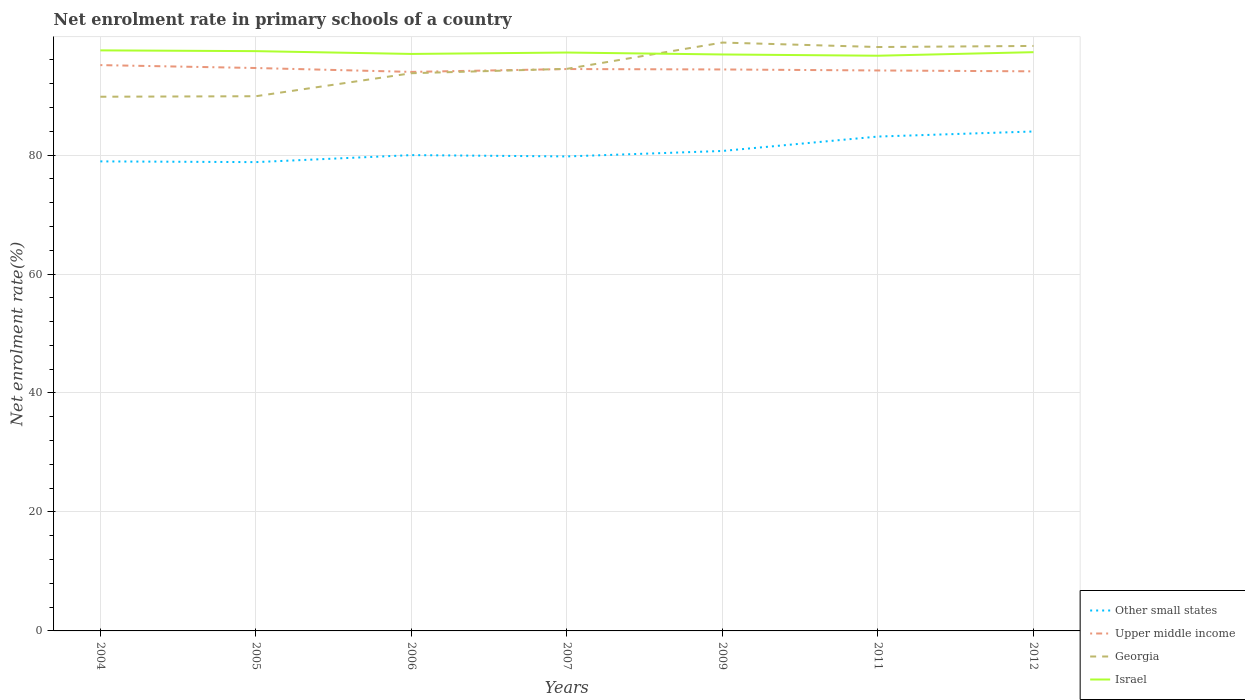How many different coloured lines are there?
Ensure brevity in your answer.  4. Does the line corresponding to Georgia intersect with the line corresponding to Upper middle income?
Provide a succinct answer. Yes. Across all years, what is the maximum net enrolment rate in primary schools in Upper middle income?
Provide a short and direct response. 93.98. What is the total net enrolment rate in primary schools in Upper middle income in the graph?
Keep it short and to the point. 0.24. What is the difference between the highest and the second highest net enrolment rate in primary schools in Israel?
Provide a short and direct response. 0.9. Is the net enrolment rate in primary schools in Georgia strictly greater than the net enrolment rate in primary schools in Upper middle income over the years?
Your answer should be very brief. No. How many lines are there?
Offer a terse response. 4. How many years are there in the graph?
Give a very brief answer. 7. Are the values on the major ticks of Y-axis written in scientific E-notation?
Provide a succinct answer. No. Does the graph contain grids?
Your answer should be compact. Yes. How many legend labels are there?
Provide a short and direct response. 4. What is the title of the graph?
Your answer should be compact. Net enrolment rate in primary schools of a country. Does "Cayman Islands" appear as one of the legend labels in the graph?
Your answer should be compact. No. What is the label or title of the Y-axis?
Ensure brevity in your answer.  Net enrolment rate(%). What is the Net enrolment rate(%) in Other small states in 2004?
Make the answer very short. 78.94. What is the Net enrolment rate(%) of Upper middle income in 2004?
Keep it short and to the point. 95.12. What is the Net enrolment rate(%) of Georgia in 2004?
Ensure brevity in your answer.  89.81. What is the Net enrolment rate(%) of Israel in 2004?
Ensure brevity in your answer.  97.6. What is the Net enrolment rate(%) of Other small states in 2005?
Provide a succinct answer. 78.81. What is the Net enrolment rate(%) of Upper middle income in 2005?
Provide a succinct answer. 94.64. What is the Net enrolment rate(%) in Georgia in 2005?
Your response must be concise. 89.89. What is the Net enrolment rate(%) in Israel in 2005?
Provide a succinct answer. 97.47. What is the Net enrolment rate(%) in Other small states in 2006?
Your answer should be compact. 79.99. What is the Net enrolment rate(%) in Upper middle income in 2006?
Your answer should be compact. 93.98. What is the Net enrolment rate(%) in Georgia in 2006?
Provide a succinct answer. 93.76. What is the Net enrolment rate(%) of Israel in 2006?
Keep it short and to the point. 97. What is the Net enrolment rate(%) in Other small states in 2007?
Ensure brevity in your answer.  79.77. What is the Net enrolment rate(%) in Upper middle income in 2007?
Provide a succinct answer. 94.46. What is the Net enrolment rate(%) in Georgia in 2007?
Offer a very short reply. 94.5. What is the Net enrolment rate(%) of Israel in 2007?
Your response must be concise. 97.24. What is the Net enrolment rate(%) of Other small states in 2009?
Provide a succinct answer. 80.69. What is the Net enrolment rate(%) of Upper middle income in 2009?
Make the answer very short. 94.39. What is the Net enrolment rate(%) of Georgia in 2009?
Your answer should be very brief. 98.92. What is the Net enrolment rate(%) of Israel in 2009?
Give a very brief answer. 96.91. What is the Net enrolment rate(%) in Other small states in 2011?
Make the answer very short. 83.11. What is the Net enrolment rate(%) of Upper middle income in 2011?
Provide a short and direct response. 94.22. What is the Net enrolment rate(%) of Georgia in 2011?
Your response must be concise. 98.16. What is the Net enrolment rate(%) of Israel in 2011?
Keep it short and to the point. 96.7. What is the Net enrolment rate(%) of Other small states in 2012?
Offer a very short reply. 83.97. What is the Net enrolment rate(%) of Upper middle income in 2012?
Provide a succinct answer. 94.08. What is the Net enrolment rate(%) in Georgia in 2012?
Ensure brevity in your answer.  98.35. What is the Net enrolment rate(%) in Israel in 2012?
Offer a terse response. 97.3. Across all years, what is the maximum Net enrolment rate(%) of Other small states?
Offer a terse response. 83.97. Across all years, what is the maximum Net enrolment rate(%) in Upper middle income?
Provide a succinct answer. 95.12. Across all years, what is the maximum Net enrolment rate(%) of Georgia?
Your response must be concise. 98.92. Across all years, what is the maximum Net enrolment rate(%) in Israel?
Your answer should be compact. 97.6. Across all years, what is the minimum Net enrolment rate(%) of Other small states?
Your answer should be compact. 78.81. Across all years, what is the minimum Net enrolment rate(%) in Upper middle income?
Your answer should be compact. 93.98. Across all years, what is the minimum Net enrolment rate(%) of Georgia?
Offer a terse response. 89.81. Across all years, what is the minimum Net enrolment rate(%) of Israel?
Ensure brevity in your answer.  96.7. What is the total Net enrolment rate(%) in Other small states in the graph?
Offer a very short reply. 565.29. What is the total Net enrolment rate(%) in Upper middle income in the graph?
Keep it short and to the point. 660.89. What is the total Net enrolment rate(%) of Georgia in the graph?
Give a very brief answer. 663.38. What is the total Net enrolment rate(%) in Israel in the graph?
Provide a short and direct response. 680.22. What is the difference between the Net enrolment rate(%) in Other small states in 2004 and that in 2005?
Provide a succinct answer. 0.12. What is the difference between the Net enrolment rate(%) in Upper middle income in 2004 and that in 2005?
Give a very brief answer. 0.49. What is the difference between the Net enrolment rate(%) in Georgia in 2004 and that in 2005?
Provide a short and direct response. -0.09. What is the difference between the Net enrolment rate(%) of Israel in 2004 and that in 2005?
Offer a very short reply. 0.13. What is the difference between the Net enrolment rate(%) in Other small states in 2004 and that in 2006?
Give a very brief answer. -1.05. What is the difference between the Net enrolment rate(%) of Upper middle income in 2004 and that in 2006?
Provide a succinct answer. 1.14. What is the difference between the Net enrolment rate(%) of Georgia in 2004 and that in 2006?
Keep it short and to the point. -3.95. What is the difference between the Net enrolment rate(%) of Israel in 2004 and that in 2006?
Your answer should be very brief. 0.6. What is the difference between the Net enrolment rate(%) in Other small states in 2004 and that in 2007?
Your response must be concise. -0.83. What is the difference between the Net enrolment rate(%) of Upper middle income in 2004 and that in 2007?
Make the answer very short. 0.66. What is the difference between the Net enrolment rate(%) in Georgia in 2004 and that in 2007?
Ensure brevity in your answer.  -4.69. What is the difference between the Net enrolment rate(%) of Israel in 2004 and that in 2007?
Give a very brief answer. 0.36. What is the difference between the Net enrolment rate(%) in Other small states in 2004 and that in 2009?
Offer a terse response. -1.75. What is the difference between the Net enrolment rate(%) of Upper middle income in 2004 and that in 2009?
Provide a succinct answer. 0.73. What is the difference between the Net enrolment rate(%) in Georgia in 2004 and that in 2009?
Keep it short and to the point. -9.11. What is the difference between the Net enrolment rate(%) in Israel in 2004 and that in 2009?
Your answer should be compact. 0.69. What is the difference between the Net enrolment rate(%) in Other small states in 2004 and that in 2011?
Offer a very short reply. -4.18. What is the difference between the Net enrolment rate(%) of Upper middle income in 2004 and that in 2011?
Your response must be concise. 0.9. What is the difference between the Net enrolment rate(%) of Georgia in 2004 and that in 2011?
Offer a very short reply. -8.36. What is the difference between the Net enrolment rate(%) in Israel in 2004 and that in 2011?
Keep it short and to the point. 0.9. What is the difference between the Net enrolment rate(%) in Other small states in 2004 and that in 2012?
Make the answer very short. -5.03. What is the difference between the Net enrolment rate(%) in Upper middle income in 2004 and that in 2012?
Your answer should be very brief. 1.05. What is the difference between the Net enrolment rate(%) in Georgia in 2004 and that in 2012?
Ensure brevity in your answer.  -8.54. What is the difference between the Net enrolment rate(%) of Israel in 2004 and that in 2012?
Keep it short and to the point. 0.3. What is the difference between the Net enrolment rate(%) in Other small states in 2005 and that in 2006?
Your response must be concise. -1.18. What is the difference between the Net enrolment rate(%) of Upper middle income in 2005 and that in 2006?
Your answer should be compact. 0.65. What is the difference between the Net enrolment rate(%) in Georgia in 2005 and that in 2006?
Your response must be concise. -3.87. What is the difference between the Net enrolment rate(%) of Israel in 2005 and that in 2006?
Your answer should be very brief. 0.47. What is the difference between the Net enrolment rate(%) in Other small states in 2005 and that in 2007?
Your answer should be compact. -0.96. What is the difference between the Net enrolment rate(%) of Upper middle income in 2005 and that in 2007?
Ensure brevity in your answer.  0.17. What is the difference between the Net enrolment rate(%) in Georgia in 2005 and that in 2007?
Provide a succinct answer. -4.61. What is the difference between the Net enrolment rate(%) of Israel in 2005 and that in 2007?
Your response must be concise. 0.23. What is the difference between the Net enrolment rate(%) in Other small states in 2005 and that in 2009?
Your answer should be very brief. -1.88. What is the difference between the Net enrolment rate(%) of Upper middle income in 2005 and that in 2009?
Provide a short and direct response. 0.24. What is the difference between the Net enrolment rate(%) of Georgia in 2005 and that in 2009?
Your response must be concise. -9.02. What is the difference between the Net enrolment rate(%) of Israel in 2005 and that in 2009?
Ensure brevity in your answer.  0.56. What is the difference between the Net enrolment rate(%) in Other small states in 2005 and that in 2011?
Your answer should be very brief. -4.3. What is the difference between the Net enrolment rate(%) of Upper middle income in 2005 and that in 2011?
Your response must be concise. 0.41. What is the difference between the Net enrolment rate(%) of Georgia in 2005 and that in 2011?
Provide a succinct answer. -8.27. What is the difference between the Net enrolment rate(%) of Israel in 2005 and that in 2011?
Give a very brief answer. 0.77. What is the difference between the Net enrolment rate(%) of Other small states in 2005 and that in 2012?
Offer a very short reply. -5.15. What is the difference between the Net enrolment rate(%) in Upper middle income in 2005 and that in 2012?
Make the answer very short. 0.56. What is the difference between the Net enrolment rate(%) in Georgia in 2005 and that in 2012?
Offer a very short reply. -8.45. What is the difference between the Net enrolment rate(%) of Israel in 2005 and that in 2012?
Offer a very short reply. 0.17. What is the difference between the Net enrolment rate(%) of Other small states in 2006 and that in 2007?
Keep it short and to the point. 0.22. What is the difference between the Net enrolment rate(%) of Upper middle income in 2006 and that in 2007?
Give a very brief answer. -0.48. What is the difference between the Net enrolment rate(%) of Georgia in 2006 and that in 2007?
Provide a short and direct response. -0.74. What is the difference between the Net enrolment rate(%) of Israel in 2006 and that in 2007?
Offer a terse response. -0.23. What is the difference between the Net enrolment rate(%) of Other small states in 2006 and that in 2009?
Your answer should be very brief. -0.7. What is the difference between the Net enrolment rate(%) in Upper middle income in 2006 and that in 2009?
Give a very brief answer. -0.41. What is the difference between the Net enrolment rate(%) in Georgia in 2006 and that in 2009?
Make the answer very short. -5.16. What is the difference between the Net enrolment rate(%) in Israel in 2006 and that in 2009?
Make the answer very short. 0.09. What is the difference between the Net enrolment rate(%) in Other small states in 2006 and that in 2011?
Provide a short and direct response. -3.12. What is the difference between the Net enrolment rate(%) in Upper middle income in 2006 and that in 2011?
Provide a short and direct response. -0.24. What is the difference between the Net enrolment rate(%) of Georgia in 2006 and that in 2011?
Keep it short and to the point. -4.4. What is the difference between the Net enrolment rate(%) of Israel in 2006 and that in 2011?
Provide a succinct answer. 0.3. What is the difference between the Net enrolment rate(%) in Other small states in 2006 and that in 2012?
Your answer should be compact. -3.97. What is the difference between the Net enrolment rate(%) of Upper middle income in 2006 and that in 2012?
Your response must be concise. -0.09. What is the difference between the Net enrolment rate(%) in Georgia in 2006 and that in 2012?
Make the answer very short. -4.59. What is the difference between the Net enrolment rate(%) of Israel in 2006 and that in 2012?
Provide a succinct answer. -0.3. What is the difference between the Net enrolment rate(%) in Other small states in 2007 and that in 2009?
Keep it short and to the point. -0.92. What is the difference between the Net enrolment rate(%) of Upper middle income in 2007 and that in 2009?
Give a very brief answer. 0.07. What is the difference between the Net enrolment rate(%) of Georgia in 2007 and that in 2009?
Ensure brevity in your answer.  -4.42. What is the difference between the Net enrolment rate(%) of Israel in 2007 and that in 2009?
Provide a succinct answer. 0.33. What is the difference between the Net enrolment rate(%) in Other small states in 2007 and that in 2011?
Provide a short and direct response. -3.34. What is the difference between the Net enrolment rate(%) in Upper middle income in 2007 and that in 2011?
Provide a short and direct response. 0.24. What is the difference between the Net enrolment rate(%) in Georgia in 2007 and that in 2011?
Make the answer very short. -3.66. What is the difference between the Net enrolment rate(%) in Israel in 2007 and that in 2011?
Your answer should be compact. 0.54. What is the difference between the Net enrolment rate(%) in Other small states in 2007 and that in 2012?
Offer a terse response. -4.19. What is the difference between the Net enrolment rate(%) of Upper middle income in 2007 and that in 2012?
Provide a succinct answer. 0.39. What is the difference between the Net enrolment rate(%) of Georgia in 2007 and that in 2012?
Provide a succinct answer. -3.85. What is the difference between the Net enrolment rate(%) in Israel in 2007 and that in 2012?
Offer a terse response. -0.06. What is the difference between the Net enrolment rate(%) of Other small states in 2009 and that in 2011?
Provide a succinct answer. -2.42. What is the difference between the Net enrolment rate(%) in Upper middle income in 2009 and that in 2011?
Give a very brief answer. 0.17. What is the difference between the Net enrolment rate(%) of Georgia in 2009 and that in 2011?
Your response must be concise. 0.75. What is the difference between the Net enrolment rate(%) of Israel in 2009 and that in 2011?
Provide a short and direct response. 0.21. What is the difference between the Net enrolment rate(%) of Other small states in 2009 and that in 2012?
Your answer should be very brief. -3.28. What is the difference between the Net enrolment rate(%) of Upper middle income in 2009 and that in 2012?
Make the answer very short. 0.32. What is the difference between the Net enrolment rate(%) in Georgia in 2009 and that in 2012?
Keep it short and to the point. 0.57. What is the difference between the Net enrolment rate(%) in Israel in 2009 and that in 2012?
Make the answer very short. -0.39. What is the difference between the Net enrolment rate(%) of Other small states in 2011 and that in 2012?
Provide a short and direct response. -0.85. What is the difference between the Net enrolment rate(%) of Upper middle income in 2011 and that in 2012?
Keep it short and to the point. 0.15. What is the difference between the Net enrolment rate(%) of Georgia in 2011 and that in 2012?
Keep it short and to the point. -0.18. What is the difference between the Net enrolment rate(%) of Israel in 2011 and that in 2012?
Ensure brevity in your answer.  -0.6. What is the difference between the Net enrolment rate(%) of Other small states in 2004 and the Net enrolment rate(%) of Upper middle income in 2005?
Make the answer very short. -15.7. What is the difference between the Net enrolment rate(%) of Other small states in 2004 and the Net enrolment rate(%) of Georgia in 2005?
Keep it short and to the point. -10.95. What is the difference between the Net enrolment rate(%) of Other small states in 2004 and the Net enrolment rate(%) of Israel in 2005?
Keep it short and to the point. -18.53. What is the difference between the Net enrolment rate(%) of Upper middle income in 2004 and the Net enrolment rate(%) of Georgia in 2005?
Give a very brief answer. 5.23. What is the difference between the Net enrolment rate(%) of Upper middle income in 2004 and the Net enrolment rate(%) of Israel in 2005?
Your answer should be compact. -2.35. What is the difference between the Net enrolment rate(%) of Georgia in 2004 and the Net enrolment rate(%) of Israel in 2005?
Give a very brief answer. -7.66. What is the difference between the Net enrolment rate(%) of Other small states in 2004 and the Net enrolment rate(%) of Upper middle income in 2006?
Your answer should be very brief. -15.04. What is the difference between the Net enrolment rate(%) in Other small states in 2004 and the Net enrolment rate(%) in Georgia in 2006?
Your response must be concise. -14.82. What is the difference between the Net enrolment rate(%) of Other small states in 2004 and the Net enrolment rate(%) of Israel in 2006?
Offer a terse response. -18.06. What is the difference between the Net enrolment rate(%) of Upper middle income in 2004 and the Net enrolment rate(%) of Georgia in 2006?
Make the answer very short. 1.36. What is the difference between the Net enrolment rate(%) in Upper middle income in 2004 and the Net enrolment rate(%) in Israel in 2006?
Give a very brief answer. -1.88. What is the difference between the Net enrolment rate(%) of Georgia in 2004 and the Net enrolment rate(%) of Israel in 2006?
Make the answer very short. -7.2. What is the difference between the Net enrolment rate(%) in Other small states in 2004 and the Net enrolment rate(%) in Upper middle income in 2007?
Provide a short and direct response. -15.52. What is the difference between the Net enrolment rate(%) in Other small states in 2004 and the Net enrolment rate(%) in Georgia in 2007?
Offer a terse response. -15.56. What is the difference between the Net enrolment rate(%) in Other small states in 2004 and the Net enrolment rate(%) in Israel in 2007?
Offer a terse response. -18.3. What is the difference between the Net enrolment rate(%) in Upper middle income in 2004 and the Net enrolment rate(%) in Georgia in 2007?
Your answer should be compact. 0.63. What is the difference between the Net enrolment rate(%) of Upper middle income in 2004 and the Net enrolment rate(%) of Israel in 2007?
Keep it short and to the point. -2.11. What is the difference between the Net enrolment rate(%) of Georgia in 2004 and the Net enrolment rate(%) of Israel in 2007?
Your answer should be very brief. -7.43. What is the difference between the Net enrolment rate(%) in Other small states in 2004 and the Net enrolment rate(%) in Upper middle income in 2009?
Provide a short and direct response. -15.45. What is the difference between the Net enrolment rate(%) in Other small states in 2004 and the Net enrolment rate(%) in Georgia in 2009?
Your answer should be very brief. -19.98. What is the difference between the Net enrolment rate(%) of Other small states in 2004 and the Net enrolment rate(%) of Israel in 2009?
Your answer should be very brief. -17.97. What is the difference between the Net enrolment rate(%) in Upper middle income in 2004 and the Net enrolment rate(%) in Georgia in 2009?
Your answer should be compact. -3.79. What is the difference between the Net enrolment rate(%) of Upper middle income in 2004 and the Net enrolment rate(%) of Israel in 2009?
Offer a terse response. -1.79. What is the difference between the Net enrolment rate(%) in Georgia in 2004 and the Net enrolment rate(%) in Israel in 2009?
Ensure brevity in your answer.  -7.1. What is the difference between the Net enrolment rate(%) of Other small states in 2004 and the Net enrolment rate(%) of Upper middle income in 2011?
Offer a very short reply. -15.29. What is the difference between the Net enrolment rate(%) of Other small states in 2004 and the Net enrolment rate(%) of Georgia in 2011?
Your answer should be compact. -19.22. What is the difference between the Net enrolment rate(%) in Other small states in 2004 and the Net enrolment rate(%) in Israel in 2011?
Keep it short and to the point. -17.76. What is the difference between the Net enrolment rate(%) of Upper middle income in 2004 and the Net enrolment rate(%) of Georgia in 2011?
Your answer should be compact. -3.04. What is the difference between the Net enrolment rate(%) of Upper middle income in 2004 and the Net enrolment rate(%) of Israel in 2011?
Offer a very short reply. -1.58. What is the difference between the Net enrolment rate(%) of Georgia in 2004 and the Net enrolment rate(%) of Israel in 2011?
Your answer should be compact. -6.89. What is the difference between the Net enrolment rate(%) of Other small states in 2004 and the Net enrolment rate(%) of Upper middle income in 2012?
Your response must be concise. -15.14. What is the difference between the Net enrolment rate(%) of Other small states in 2004 and the Net enrolment rate(%) of Georgia in 2012?
Offer a very short reply. -19.41. What is the difference between the Net enrolment rate(%) in Other small states in 2004 and the Net enrolment rate(%) in Israel in 2012?
Offer a terse response. -18.36. What is the difference between the Net enrolment rate(%) of Upper middle income in 2004 and the Net enrolment rate(%) of Georgia in 2012?
Your answer should be compact. -3.22. What is the difference between the Net enrolment rate(%) in Upper middle income in 2004 and the Net enrolment rate(%) in Israel in 2012?
Give a very brief answer. -2.18. What is the difference between the Net enrolment rate(%) in Georgia in 2004 and the Net enrolment rate(%) in Israel in 2012?
Ensure brevity in your answer.  -7.49. What is the difference between the Net enrolment rate(%) of Other small states in 2005 and the Net enrolment rate(%) of Upper middle income in 2006?
Make the answer very short. -15.17. What is the difference between the Net enrolment rate(%) in Other small states in 2005 and the Net enrolment rate(%) in Georgia in 2006?
Offer a very short reply. -14.94. What is the difference between the Net enrolment rate(%) in Other small states in 2005 and the Net enrolment rate(%) in Israel in 2006?
Give a very brief answer. -18.19. What is the difference between the Net enrolment rate(%) in Upper middle income in 2005 and the Net enrolment rate(%) in Georgia in 2006?
Make the answer very short. 0.88. What is the difference between the Net enrolment rate(%) in Upper middle income in 2005 and the Net enrolment rate(%) in Israel in 2006?
Offer a very short reply. -2.37. What is the difference between the Net enrolment rate(%) in Georgia in 2005 and the Net enrolment rate(%) in Israel in 2006?
Your answer should be very brief. -7.11. What is the difference between the Net enrolment rate(%) of Other small states in 2005 and the Net enrolment rate(%) of Upper middle income in 2007?
Offer a terse response. -15.65. What is the difference between the Net enrolment rate(%) of Other small states in 2005 and the Net enrolment rate(%) of Georgia in 2007?
Offer a terse response. -15.68. What is the difference between the Net enrolment rate(%) in Other small states in 2005 and the Net enrolment rate(%) in Israel in 2007?
Make the answer very short. -18.42. What is the difference between the Net enrolment rate(%) of Upper middle income in 2005 and the Net enrolment rate(%) of Georgia in 2007?
Keep it short and to the point. 0.14. What is the difference between the Net enrolment rate(%) of Upper middle income in 2005 and the Net enrolment rate(%) of Israel in 2007?
Your answer should be very brief. -2.6. What is the difference between the Net enrolment rate(%) in Georgia in 2005 and the Net enrolment rate(%) in Israel in 2007?
Give a very brief answer. -7.34. What is the difference between the Net enrolment rate(%) of Other small states in 2005 and the Net enrolment rate(%) of Upper middle income in 2009?
Your response must be concise. -15.58. What is the difference between the Net enrolment rate(%) of Other small states in 2005 and the Net enrolment rate(%) of Georgia in 2009?
Offer a very short reply. -20.1. What is the difference between the Net enrolment rate(%) of Other small states in 2005 and the Net enrolment rate(%) of Israel in 2009?
Keep it short and to the point. -18.1. What is the difference between the Net enrolment rate(%) in Upper middle income in 2005 and the Net enrolment rate(%) in Georgia in 2009?
Provide a short and direct response. -4.28. What is the difference between the Net enrolment rate(%) in Upper middle income in 2005 and the Net enrolment rate(%) in Israel in 2009?
Ensure brevity in your answer.  -2.28. What is the difference between the Net enrolment rate(%) in Georgia in 2005 and the Net enrolment rate(%) in Israel in 2009?
Make the answer very short. -7.02. What is the difference between the Net enrolment rate(%) in Other small states in 2005 and the Net enrolment rate(%) in Upper middle income in 2011?
Your response must be concise. -15.41. What is the difference between the Net enrolment rate(%) in Other small states in 2005 and the Net enrolment rate(%) in Georgia in 2011?
Provide a short and direct response. -19.35. What is the difference between the Net enrolment rate(%) in Other small states in 2005 and the Net enrolment rate(%) in Israel in 2011?
Your response must be concise. -17.89. What is the difference between the Net enrolment rate(%) in Upper middle income in 2005 and the Net enrolment rate(%) in Georgia in 2011?
Offer a terse response. -3.53. What is the difference between the Net enrolment rate(%) of Upper middle income in 2005 and the Net enrolment rate(%) of Israel in 2011?
Offer a terse response. -2.07. What is the difference between the Net enrolment rate(%) of Georgia in 2005 and the Net enrolment rate(%) of Israel in 2011?
Ensure brevity in your answer.  -6.81. What is the difference between the Net enrolment rate(%) of Other small states in 2005 and the Net enrolment rate(%) of Upper middle income in 2012?
Offer a very short reply. -15.26. What is the difference between the Net enrolment rate(%) in Other small states in 2005 and the Net enrolment rate(%) in Georgia in 2012?
Your answer should be very brief. -19.53. What is the difference between the Net enrolment rate(%) of Other small states in 2005 and the Net enrolment rate(%) of Israel in 2012?
Offer a terse response. -18.48. What is the difference between the Net enrolment rate(%) of Upper middle income in 2005 and the Net enrolment rate(%) of Georgia in 2012?
Offer a terse response. -3.71. What is the difference between the Net enrolment rate(%) of Upper middle income in 2005 and the Net enrolment rate(%) of Israel in 2012?
Offer a very short reply. -2.66. What is the difference between the Net enrolment rate(%) of Georgia in 2005 and the Net enrolment rate(%) of Israel in 2012?
Make the answer very short. -7.41. What is the difference between the Net enrolment rate(%) in Other small states in 2006 and the Net enrolment rate(%) in Upper middle income in 2007?
Make the answer very short. -14.47. What is the difference between the Net enrolment rate(%) in Other small states in 2006 and the Net enrolment rate(%) in Georgia in 2007?
Your answer should be very brief. -14.51. What is the difference between the Net enrolment rate(%) of Other small states in 2006 and the Net enrolment rate(%) of Israel in 2007?
Your answer should be compact. -17.25. What is the difference between the Net enrolment rate(%) in Upper middle income in 2006 and the Net enrolment rate(%) in Georgia in 2007?
Make the answer very short. -0.52. What is the difference between the Net enrolment rate(%) in Upper middle income in 2006 and the Net enrolment rate(%) in Israel in 2007?
Offer a terse response. -3.26. What is the difference between the Net enrolment rate(%) of Georgia in 2006 and the Net enrolment rate(%) of Israel in 2007?
Your answer should be compact. -3.48. What is the difference between the Net enrolment rate(%) of Other small states in 2006 and the Net enrolment rate(%) of Upper middle income in 2009?
Keep it short and to the point. -14.4. What is the difference between the Net enrolment rate(%) of Other small states in 2006 and the Net enrolment rate(%) of Georgia in 2009?
Keep it short and to the point. -18.92. What is the difference between the Net enrolment rate(%) in Other small states in 2006 and the Net enrolment rate(%) in Israel in 2009?
Your response must be concise. -16.92. What is the difference between the Net enrolment rate(%) in Upper middle income in 2006 and the Net enrolment rate(%) in Georgia in 2009?
Ensure brevity in your answer.  -4.93. What is the difference between the Net enrolment rate(%) in Upper middle income in 2006 and the Net enrolment rate(%) in Israel in 2009?
Your answer should be compact. -2.93. What is the difference between the Net enrolment rate(%) of Georgia in 2006 and the Net enrolment rate(%) of Israel in 2009?
Provide a succinct answer. -3.15. What is the difference between the Net enrolment rate(%) in Other small states in 2006 and the Net enrolment rate(%) in Upper middle income in 2011?
Your answer should be very brief. -14.23. What is the difference between the Net enrolment rate(%) of Other small states in 2006 and the Net enrolment rate(%) of Georgia in 2011?
Your answer should be very brief. -18.17. What is the difference between the Net enrolment rate(%) of Other small states in 2006 and the Net enrolment rate(%) of Israel in 2011?
Keep it short and to the point. -16.71. What is the difference between the Net enrolment rate(%) of Upper middle income in 2006 and the Net enrolment rate(%) of Georgia in 2011?
Your response must be concise. -4.18. What is the difference between the Net enrolment rate(%) in Upper middle income in 2006 and the Net enrolment rate(%) in Israel in 2011?
Keep it short and to the point. -2.72. What is the difference between the Net enrolment rate(%) of Georgia in 2006 and the Net enrolment rate(%) of Israel in 2011?
Your response must be concise. -2.94. What is the difference between the Net enrolment rate(%) of Other small states in 2006 and the Net enrolment rate(%) of Upper middle income in 2012?
Provide a succinct answer. -14.08. What is the difference between the Net enrolment rate(%) of Other small states in 2006 and the Net enrolment rate(%) of Georgia in 2012?
Your response must be concise. -18.35. What is the difference between the Net enrolment rate(%) of Other small states in 2006 and the Net enrolment rate(%) of Israel in 2012?
Ensure brevity in your answer.  -17.31. What is the difference between the Net enrolment rate(%) in Upper middle income in 2006 and the Net enrolment rate(%) in Georgia in 2012?
Provide a succinct answer. -4.36. What is the difference between the Net enrolment rate(%) of Upper middle income in 2006 and the Net enrolment rate(%) of Israel in 2012?
Keep it short and to the point. -3.32. What is the difference between the Net enrolment rate(%) in Georgia in 2006 and the Net enrolment rate(%) in Israel in 2012?
Give a very brief answer. -3.54. What is the difference between the Net enrolment rate(%) of Other small states in 2007 and the Net enrolment rate(%) of Upper middle income in 2009?
Provide a succinct answer. -14.62. What is the difference between the Net enrolment rate(%) in Other small states in 2007 and the Net enrolment rate(%) in Georgia in 2009?
Provide a short and direct response. -19.14. What is the difference between the Net enrolment rate(%) of Other small states in 2007 and the Net enrolment rate(%) of Israel in 2009?
Provide a short and direct response. -17.14. What is the difference between the Net enrolment rate(%) of Upper middle income in 2007 and the Net enrolment rate(%) of Georgia in 2009?
Offer a terse response. -4.45. What is the difference between the Net enrolment rate(%) of Upper middle income in 2007 and the Net enrolment rate(%) of Israel in 2009?
Your response must be concise. -2.45. What is the difference between the Net enrolment rate(%) of Georgia in 2007 and the Net enrolment rate(%) of Israel in 2009?
Your answer should be very brief. -2.41. What is the difference between the Net enrolment rate(%) in Other small states in 2007 and the Net enrolment rate(%) in Upper middle income in 2011?
Offer a terse response. -14.45. What is the difference between the Net enrolment rate(%) in Other small states in 2007 and the Net enrolment rate(%) in Georgia in 2011?
Your response must be concise. -18.39. What is the difference between the Net enrolment rate(%) of Other small states in 2007 and the Net enrolment rate(%) of Israel in 2011?
Provide a short and direct response. -16.93. What is the difference between the Net enrolment rate(%) of Upper middle income in 2007 and the Net enrolment rate(%) of Georgia in 2011?
Offer a terse response. -3.7. What is the difference between the Net enrolment rate(%) of Upper middle income in 2007 and the Net enrolment rate(%) of Israel in 2011?
Provide a short and direct response. -2.24. What is the difference between the Net enrolment rate(%) in Georgia in 2007 and the Net enrolment rate(%) in Israel in 2011?
Your answer should be very brief. -2.2. What is the difference between the Net enrolment rate(%) of Other small states in 2007 and the Net enrolment rate(%) of Upper middle income in 2012?
Ensure brevity in your answer.  -14.3. What is the difference between the Net enrolment rate(%) in Other small states in 2007 and the Net enrolment rate(%) in Georgia in 2012?
Your answer should be very brief. -18.57. What is the difference between the Net enrolment rate(%) in Other small states in 2007 and the Net enrolment rate(%) in Israel in 2012?
Ensure brevity in your answer.  -17.53. What is the difference between the Net enrolment rate(%) of Upper middle income in 2007 and the Net enrolment rate(%) of Georgia in 2012?
Keep it short and to the point. -3.88. What is the difference between the Net enrolment rate(%) in Upper middle income in 2007 and the Net enrolment rate(%) in Israel in 2012?
Ensure brevity in your answer.  -2.84. What is the difference between the Net enrolment rate(%) in Georgia in 2007 and the Net enrolment rate(%) in Israel in 2012?
Ensure brevity in your answer.  -2.8. What is the difference between the Net enrolment rate(%) of Other small states in 2009 and the Net enrolment rate(%) of Upper middle income in 2011?
Give a very brief answer. -13.53. What is the difference between the Net enrolment rate(%) in Other small states in 2009 and the Net enrolment rate(%) in Georgia in 2011?
Offer a terse response. -17.47. What is the difference between the Net enrolment rate(%) of Other small states in 2009 and the Net enrolment rate(%) of Israel in 2011?
Provide a short and direct response. -16.01. What is the difference between the Net enrolment rate(%) in Upper middle income in 2009 and the Net enrolment rate(%) in Georgia in 2011?
Your response must be concise. -3.77. What is the difference between the Net enrolment rate(%) of Upper middle income in 2009 and the Net enrolment rate(%) of Israel in 2011?
Offer a very short reply. -2.31. What is the difference between the Net enrolment rate(%) of Georgia in 2009 and the Net enrolment rate(%) of Israel in 2011?
Your answer should be very brief. 2.21. What is the difference between the Net enrolment rate(%) of Other small states in 2009 and the Net enrolment rate(%) of Upper middle income in 2012?
Provide a short and direct response. -13.39. What is the difference between the Net enrolment rate(%) of Other small states in 2009 and the Net enrolment rate(%) of Georgia in 2012?
Provide a succinct answer. -17.66. What is the difference between the Net enrolment rate(%) in Other small states in 2009 and the Net enrolment rate(%) in Israel in 2012?
Offer a very short reply. -16.61. What is the difference between the Net enrolment rate(%) of Upper middle income in 2009 and the Net enrolment rate(%) of Georgia in 2012?
Offer a very short reply. -3.95. What is the difference between the Net enrolment rate(%) in Upper middle income in 2009 and the Net enrolment rate(%) in Israel in 2012?
Offer a very short reply. -2.91. What is the difference between the Net enrolment rate(%) of Georgia in 2009 and the Net enrolment rate(%) of Israel in 2012?
Give a very brief answer. 1.62. What is the difference between the Net enrolment rate(%) of Other small states in 2011 and the Net enrolment rate(%) of Upper middle income in 2012?
Give a very brief answer. -10.96. What is the difference between the Net enrolment rate(%) in Other small states in 2011 and the Net enrolment rate(%) in Georgia in 2012?
Your answer should be compact. -15.23. What is the difference between the Net enrolment rate(%) in Other small states in 2011 and the Net enrolment rate(%) in Israel in 2012?
Offer a very short reply. -14.19. What is the difference between the Net enrolment rate(%) of Upper middle income in 2011 and the Net enrolment rate(%) of Georgia in 2012?
Offer a terse response. -4.12. What is the difference between the Net enrolment rate(%) of Upper middle income in 2011 and the Net enrolment rate(%) of Israel in 2012?
Your answer should be very brief. -3.08. What is the difference between the Net enrolment rate(%) in Georgia in 2011 and the Net enrolment rate(%) in Israel in 2012?
Offer a terse response. 0.86. What is the average Net enrolment rate(%) in Other small states per year?
Your answer should be compact. 80.76. What is the average Net enrolment rate(%) in Upper middle income per year?
Offer a very short reply. 94.41. What is the average Net enrolment rate(%) in Georgia per year?
Give a very brief answer. 94.77. What is the average Net enrolment rate(%) of Israel per year?
Offer a very short reply. 97.17. In the year 2004, what is the difference between the Net enrolment rate(%) in Other small states and Net enrolment rate(%) in Upper middle income?
Keep it short and to the point. -16.19. In the year 2004, what is the difference between the Net enrolment rate(%) in Other small states and Net enrolment rate(%) in Georgia?
Give a very brief answer. -10.87. In the year 2004, what is the difference between the Net enrolment rate(%) in Other small states and Net enrolment rate(%) in Israel?
Provide a succinct answer. -18.66. In the year 2004, what is the difference between the Net enrolment rate(%) of Upper middle income and Net enrolment rate(%) of Georgia?
Provide a succinct answer. 5.32. In the year 2004, what is the difference between the Net enrolment rate(%) of Upper middle income and Net enrolment rate(%) of Israel?
Provide a succinct answer. -2.48. In the year 2004, what is the difference between the Net enrolment rate(%) in Georgia and Net enrolment rate(%) in Israel?
Your answer should be very brief. -7.79. In the year 2005, what is the difference between the Net enrolment rate(%) of Other small states and Net enrolment rate(%) of Upper middle income?
Your answer should be very brief. -15.82. In the year 2005, what is the difference between the Net enrolment rate(%) of Other small states and Net enrolment rate(%) of Georgia?
Give a very brief answer. -11.08. In the year 2005, what is the difference between the Net enrolment rate(%) in Other small states and Net enrolment rate(%) in Israel?
Give a very brief answer. -18.66. In the year 2005, what is the difference between the Net enrolment rate(%) of Upper middle income and Net enrolment rate(%) of Georgia?
Your response must be concise. 4.74. In the year 2005, what is the difference between the Net enrolment rate(%) of Upper middle income and Net enrolment rate(%) of Israel?
Your answer should be compact. -2.84. In the year 2005, what is the difference between the Net enrolment rate(%) of Georgia and Net enrolment rate(%) of Israel?
Give a very brief answer. -7.58. In the year 2006, what is the difference between the Net enrolment rate(%) in Other small states and Net enrolment rate(%) in Upper middle income?
Make the answer very short. -13.99. In the year 2006, what is the difference between the Net enrolment rate(%) of Other small states and Net enrolment rate(%) of Georgia?
Offer a terse response. -13.77. In the year 2006, what is the difference between the Net enrolment rate(%) of Other small states and Net enrolment rate(%) of Israel?
Your answer should be compact. -17.01. In the year 2006, what is the difference between the Net enrolment rate(%) of Upper middle income and Net enrolment rate(%) of Georgia?
Keep it short and to the point. 0.22. In the year 2006, what is the difference between the Net enrolment rate(%) in Upper middle income and Net enrolment rate(%) in Israel?
Your response must be concise. -3.02. In the year 2006, what is the difference between the Net enrolment rate(%) in Georgia and Net enrolment rate(%) in Israel?
Offer a very short reply. -3.24. In the year 2007, what is the difference between the Net enrolment rate(%) of Other small states and Net enrolment rate(%) of Upper middle income?
Give a very brief answer. -14.69. In the year 2007, what is the difference between the Net enrolment rate(%) of Other small states and Net enrolment rate(%) of Georgia?
Provide a short and direct response. -14.73. In the year 2007, what is the difference between the Net enrolment rate(%) of Other small states and Net enrolment rate(%) of Israel?
Provide a succinct answer. -17.47. In the year 2007, what is the difference between the Net enrolment rate(%) in Upper middle income and Net enrolment rate(%) in Georgia?
Keep it short and to the point. -0.04. In the year 2007, what is the difference between the Net enrolment rate(%) in Upper middle income and Net enrolment rate(%) in Israel?
Offer a terse response. -2.78. In the year 2007, what is the difference between the Net enrolment rate(%) of Georgia and Net enrolment rate(%) of Israel?
Give a very brief answer. -2.74. In the year 2009, what is the difference between the Net enrolment rate(%) of Other small states and Net enrolment rate(%) of Upper middle income?
Offer a terse response. -13.7. In the year 2009, what is the difference between the Net enrolment rate(%) of Other small states and Net enrolment rate(%) of Georgia?
Your response must be concise. -18.23. In the year 2009, what is the difference between the Net enrolment rate(%) of Other small states and Net enrolment rate(%) of Israel?
Make the answer very short. -16.22. In the year 2009, what is the difference between the Net enrolment rate(%) of Upper middle income and Net enrolment rate(%) of Georgia?
Give a very brief answer. -4.52. In the year 2009, what is the difference between the Net enrolment rate(%) of Upper middle income and Net enrolment rate(%) of Israel?
Provide a succinct answer. -2.52. In the year 2009, what is the difference between the Net enrolment rate(%) in Georgia and Net enrolment rate(%) in Israel?
Make the answer very short. 2. In the year 2011, what is the difference between the Net enrolment rate(%) of Other small states and Net enrolment rate(%) of Upper middle income?
Provide a succinct answer. -11.11. In the year 2011, what is the difference between the Net enrolment rate(%) in Other small states and Net enrolment rate(%) in Georgia?
Offer a very short reply. -15.05. In the year 2011, what is the difference between the Net enrolment rate(%) of Other small states and Net enrolment rate(%) of Israel?
Ensure brevity in your answer.  -13.59. In the year 2011, what is the difference between the Net enrolment rate(%) of Upper middle income and Net enrolment rate(%) of Georgia?
Your answer should be compact. -3.94. In the year 2011, what is the difference between the Net enrolment rate(%) of Upper middle income and Net enrolment rate(%) of Israel?
Your answer should be very brief. -2.48. In the year 2011, what is the difference between the Net enrolment rate(%) of Georgia and Net enrolment rate(%) of Israel?
Provide a succinct answer. 1.46. In the year 2012, what is the difference between the Net enrolment rate(%) of Other small states and Net enrolment rate(%) of Upper middle income?
Provide a short and direct response. -10.11. In the year 2012, what is the difference between the Net enrolment rate(%) in Other small states and Net enrolment rate(%) in Georgia?
Give a very brief answer. -14.38. In the year 2012, what is the difference between the Net enrolment rate(%) in Other small states and Net enrolment rate(%) in Israel?
Your response must be concise. -13.33. In the year 2012, what is the difference between the Net enrolment rate(%) of Upper middle income and Net enrolment rate(%) of Georgia?
Give a very brief answer. -4.27. In the year 2012, what is the difference between the Net enrolment rate(%) of Upper middle income and Net enrolment rate(%) of Israel?
Offer a very short reply. -3.22. In the year 2012, what is the difference between the Net enrolment rate(%) in Georgia and Net enrolment rate(%) in Israel?
Give a very brief answer. 1.05. What is the ratio of the Net enrolment rate(%) in Other small states in 2004 to that in 2005?
Make the answer very short. 1. What is the ratio of the Net enrolment rate(%) in Upper middle income in 2004 to that in 2005?
Offer a very short reply. 1.01. What is the ratio of the Net enrolment rate(%) of Georgia in 2004 to that in 2005?
Provide a succinct answer. 1. What is the ratio of the Net enrolment rate(%) in Israel in 2004 to that in 2005?
Make the answer very short. 1. What is the ratio of the Net enrolment rate(%) of Other small states in 2004 to that in 2006?
Your response must be concise. 0.99. What is the ratio of the Net enrolment rate(%) in Upper middle income in 2004 to that in 2006?
Offer a terse response. 1.01. What is the ratio of the Net enrolment rate(%) of Georgia in 2004 to that in 2006?
Ensure brevity in your answer.  0.96. What is the ratio of the Net enrolment rate(%) in Israel in 2004 to that in 2006?
Your answer should be compact. 1.01. What is the ratio of the Net enrolment rate(%) of Other small states in 2004 to that in 2007?
Your answer should be compact. 0.99. What is the ratio of the Net enrolment rate(%) in Upper middle income in 2004 to that in 2007?
Your answer should be compact. 1.01. What is the ratio of the Net enrolment rate(%) in Georgia in 2004 to that in 2007?
Your answer should be compact. 0.95. What is the ratio of the Net enrolment rate(%) of Other small states in 2004 to that in 2009?
Your answer should be very brief. 0.98. What is the ratio of the Net enrolment rate(%) in Georgia in 2004 to that in 2009?
Provide a succinct answer. 0.91. What is the ratio of the Net enrolment rate(%) in Israel in 2004 to that in 2009?
Ensure brevity in your answer.  1.01. What is the ratio of the Net enrolment rate(%) in Other small states in 2004 to that in 2011?
Provide a short and direct response. 0.95. What is the ratio of the Net enrolment rate(%) in Upper middle income in 2004 to that in 2011?
Your response must be concise. 1.01. What is the ratio of the Net enrolment rate(%) of Georgia in 2004 to that in 2011?
Give a very brief answer. 0.91. What is the ratio of the Net enrolment rate(%) of Israel in 2004 to that in 2011?
Make the answer very short. 1.01. What is the ratio of the Net enrolment rate(%) of Other small states in 2004 to that in 2012?
Make the answer very short. 0.94. What is the ratio of the Net enrolment rate(%) of Upper middle income in 2004 to that in 2012?
Ensure brevity in your answer.  1.01. What is the ratio of the Net enrolment rate(%) of Georgia in 2004 to that in 2012?
Provide a succinct answer. 0.91. What is the ratio of the Net enrolment rate(%) in Israel in 2004 to that in 2012?
Keep it short and to the point. 1. What is the ratio of the Net enrolment rate(%) of Georgia in 2005 to that in 2006?
Provide a succinct answer. 0.96. What is the ratio of the Net enrolment rate(%) in Upper middle income in 2005 to that in 2007?
Keep it short and to the point. 1. What is the ratio of the Net enrolment rate(%) of Georgia in 2005 to that in 2007?
Provide a succinct answer. 0.95. What is the ratio of the Net enrolment rate(%) in Israel in 2005 to that in 2007?
Your answer should be compact. 1. What is the ratio of the Net enrolment rate(%) of Other small states in 2005 to that in 2009?
Provide a short and direct response. 0.98. What is the ratio of the Net enrolment rate(%) in Georgia in 2005 to that in 2009?
Provide a short and direct response. 0.91. What is the ratio of the Net enrolment rate(%) in Israel in 2005 to that in 2009?
Make the answer very short. 1.01. What is the ratio of the Net enrolment rate(%) in Other small states in 2005 to that in 2011?
Offer a terse response. 0.95. What is the ratio of the Net enrolment rate(%) of Upper middle income in 2005 to that in 2011?
Ensure brevity in your answer.  1. What is the ratio of the Net enrolment rate(%) in Georgia in 2005 to that in 2011?
Your answer should be very brief. 0.92. What is the ratio of the Net enrolment rate(%) of Israel in 2005 to that in 2011?
Give a very brief answer. 1.01. What is the ratio of the Net enrolment rate(%) in Other small states in 2005 to that in 2012?
Give a very brief answer. 0.94. What is the ratio of the Net enrolment rate(%) in Upper middle income in 2005 to that in 2012?
Ensure brevity in your answer.  1.01. What is the ratio of the Net enrolment rate(%) in Georgia in 2005 to that in 2012?
Offer a terse response. 0.91. What is the ratio of the Net enrolment rate(%) in Israel in 2005 to that in 2012?
Provide a short and direct response. 1. What is the ratio of the Net enrolment rate(%) in Other small states in 2006 to that in 2007?
Keep it short and to the point. 1. What is the ratio of the Net enrolment rate(%) in Georgia in 2006 to that in 2007?
Keep it short and to the point. 0.99. What is the ratio of the Net enrolment rate(%) of Other small states in 2006 to that in 2009?
Ensure brevity in your answer.  0.99. What is the ratio of the Net enrolment rate(%) in Upper middle income in 2006 to that in 2009?
Offer a very short reply. 1. What is the ratio of the Net enrolment rate(%) in Georgia in 2006 to that in 2009?
Keep it short and to the point. 0.95. What is the ratio of the Net enrolment rate(%) of Israel in 2006 to that in 2009?
Your answer should be compact. 1. What is the ratio of the Net enrolment rate(%) of Other small states in 2006 to that in 2011?
Give a very brief answer. 0.96. What is the ratio of the Net enrolment rate(%) in Upper middle income in 2006 to that in 2011?
Give a very brief answer. 1. What is the ratio of the Net enrolment rate(%) of Georgia in 2006 to that in 2011?
Your answer should be very brief. 0.96. What is the ratio of the Net enrolment rate(%) of Israel in 2006 to that in 2011?
Keep it short and to the point. 1. What is the ratio of the Net enrolment rate(%) in Other small states in 2006 to that in 2012?
Ensure brevity in your answer.  0.95. What is the ratio of the Net enrolment rate(%) of Georgia in 2006 to that in 2012?
Your response must be concise. 0.95. What is the ratio of the Net enrolment rate(%) of Georgia in 2007 to that in 2009?
Your answer should be very brief. 0.96. What is the ratio of the Net enrolment rate(%) of Other small states in 2007 to that in 2011?
Your answer should be very brief. 0.96. What is the ratio of the Net enrolment rate(%) in Upper middle income in 2007 to that in 2011?
Your answer should be compact. 1. What is the ratio of the Net enrolment rate(%) in Georgia in 2007 to that in 2011?
Give a very brief answer. 0.96. What is the ratio of the Net enrolment rate(%) in Other small states in 2007 to that in 2012?
Keep it short and to the point. 0.95. What is the ratio of the Net enrolment rate(%) in Georgia in 2007 to that in 2012?
Offer a very short reply. 0.96. What is the ratio of the Net enrolment rate(%) of Israel in 2007 to that in 2012?
Keep it short and to the point. 1. What is the ratio of the Net enrolment rate(%) in Other small states in 2009 to that in 2011?
Ensure brevity in your answer.  0.97. What is the ratio of the Net enrolment rate(%) of Georgia in 2009 to that in 2011?
Make the answer very short. 1.01. What is the ratio of the Net enrolment rate(%) in Israel in 2009 to that in 2011?
Offer a terse response. 1. What is the ratio of the Net enrolment rate(%) of Other small states in 2009 to that in 2012?
Provide a succinct answer. 0.96. What is the ratio of the Net enrolment rate(%) in Upper middle income in 2009 to that in 2012?
Your answer should be very brief. 1. What is the ratio of the Net enrolment rate(%) in Georgia in 2009 to that in 2012?
Your answer should be compact. 1.01. What is the ratio of the Net enrolment rate(%) of Israel in 2009 to that in 2012?
Your answer should be compact. 1. What is the ratio of the Net enrolment rate(%) in Other small states in 2011 to that in 2012?
Give a very brief answer. 0.99. What is the ratio of the Net enrolment rate(%) in Upper middle income in 2011 to that in 2012?
Provide a short and direct response. 1. What is the ratio of the Net enrolment rate(%) in Georgia in 2011 to that in 2012?
Offer a very short reply. 1. What is the difference between the highest and the second highest Net enrolment rate(%) in Other small states?
Provide a short and direct response. 0.85. What is the difference between the highest and the second highest Net enrolment rate(%) of Upper middle income?
Keep it short and to the point. 0.49. What is the difference between the highest and the second highest Net enrolment rate(%) in Georgia?
Offer a very short reply. 0.57. What is the difference between the highest and the second highest Net enrolment rate(%) of Israel?
Offer a terse response. 0.13. What is the difference between the highest and the lowest Net enrolment rate(%) of Other small states?
Keep it short and to the point. 5.15. What is the difference between the highest and the lowest Net enrolment rate(%) in Upper middle income?
Make the answer very short. 1.14. What is the difference between the highest and the lowest Net enrolment rate(%) of Georgia?
Ensure brevity in your answer.  9.11. What is the difference between the highest and the lowest Net enrolment rate(%) of Israel?
Provide a succinct answer. 0.9. 